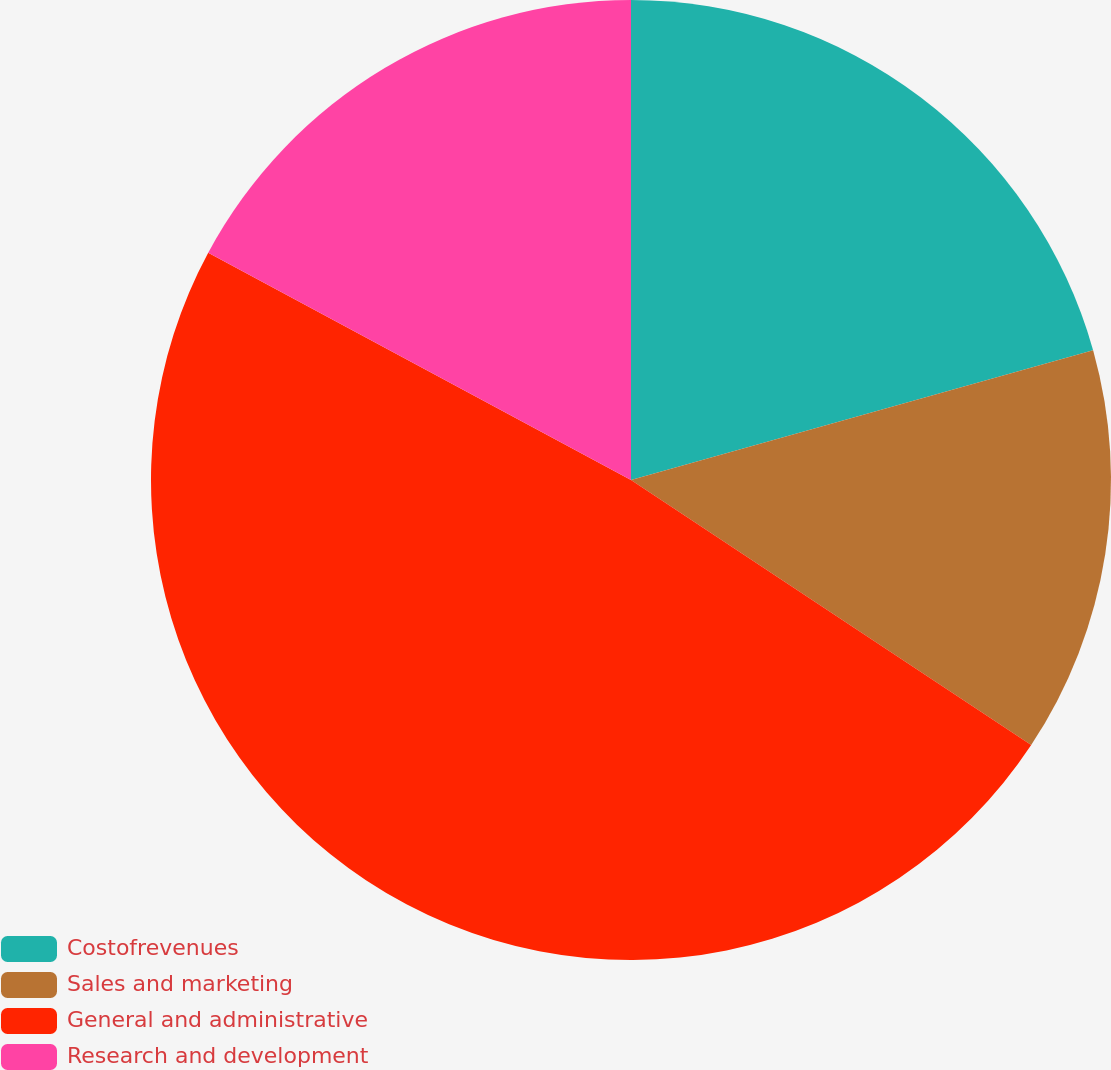<chart> <loc_0><loc_0><loc_500><loc_500><pie_chart><fcel>Costofrevenues<fcel>Sales and marketing<fcel>General and administrative<fcel>Research and development<nl><fcel>20.64%<fcel>13.67%<fcel>48.54%<fcel>17.15%<nl></chart> 